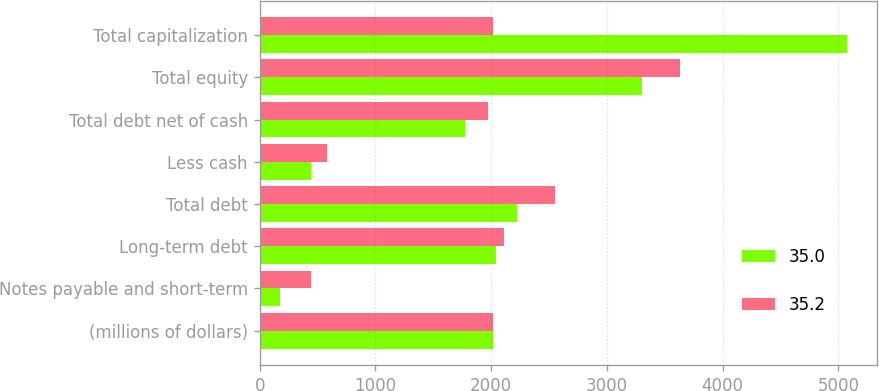Convert chart. <chart><loc_0><loc_0><loc_500><loc_500><stacked_bar_chart><ecel><fcel>(millions of dollars)<fcel>Notes payable and short-term<fcel>Long-term debt<fcel>Total debt<fcel>Less cash<fcel>Total debt net of cash<fcel>Total equity<fcel>Total capitalization<nl><fcel>35<fcel>2016<fcel>175.9<fcel>2043.6<fcel>2219.5<fcel>443.7<fcel>1775.8<fcel>3301.9<fcel>5077.7<nl><fcel>35.2<fcel>2015<fcel>441.4<fcel>2108.9<fcel>2550.3<fcel>577.7<fcel>1972.6<fcel>3631.5<fcel>2016<nl></chart> 